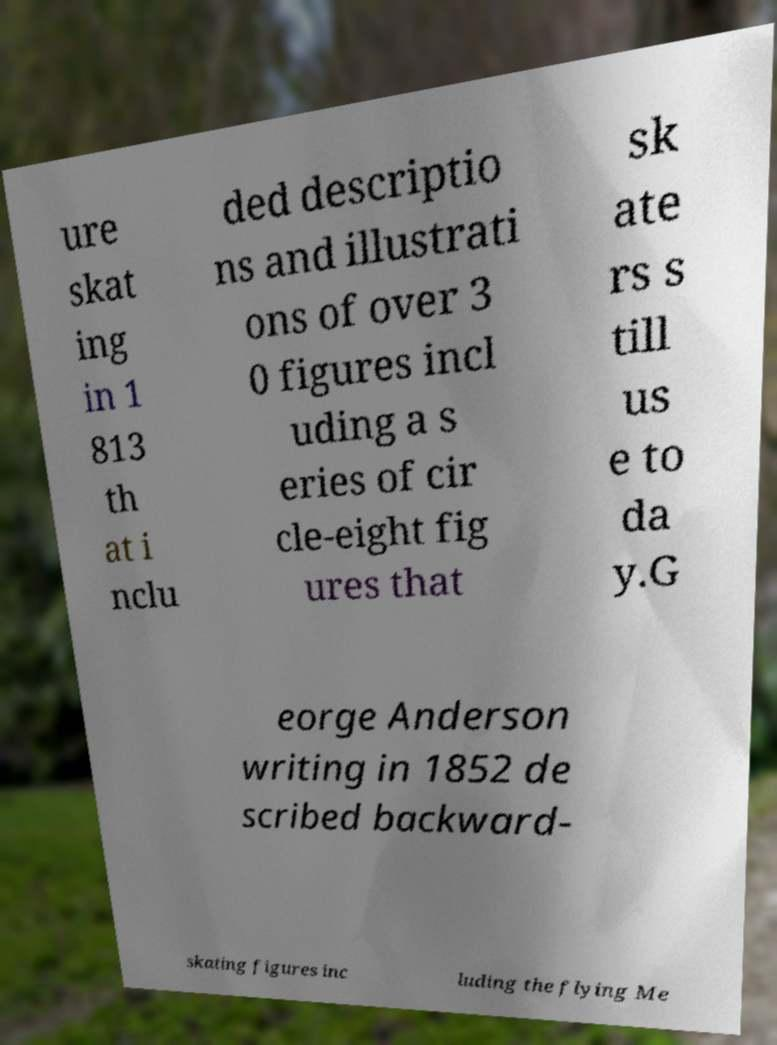Please read and relay the text visible in this image. What does it say? ure skat ing in 1 813 th at i nclu ded descriptio ns and illustrati ons of over 3 0 figures incl uding a s eries of cir cle-eight fig ures that sk ate rs s till us e to da y.G eorge Anderson writing in 1852 de scribed backward- skating figures inc luding the flying Me 